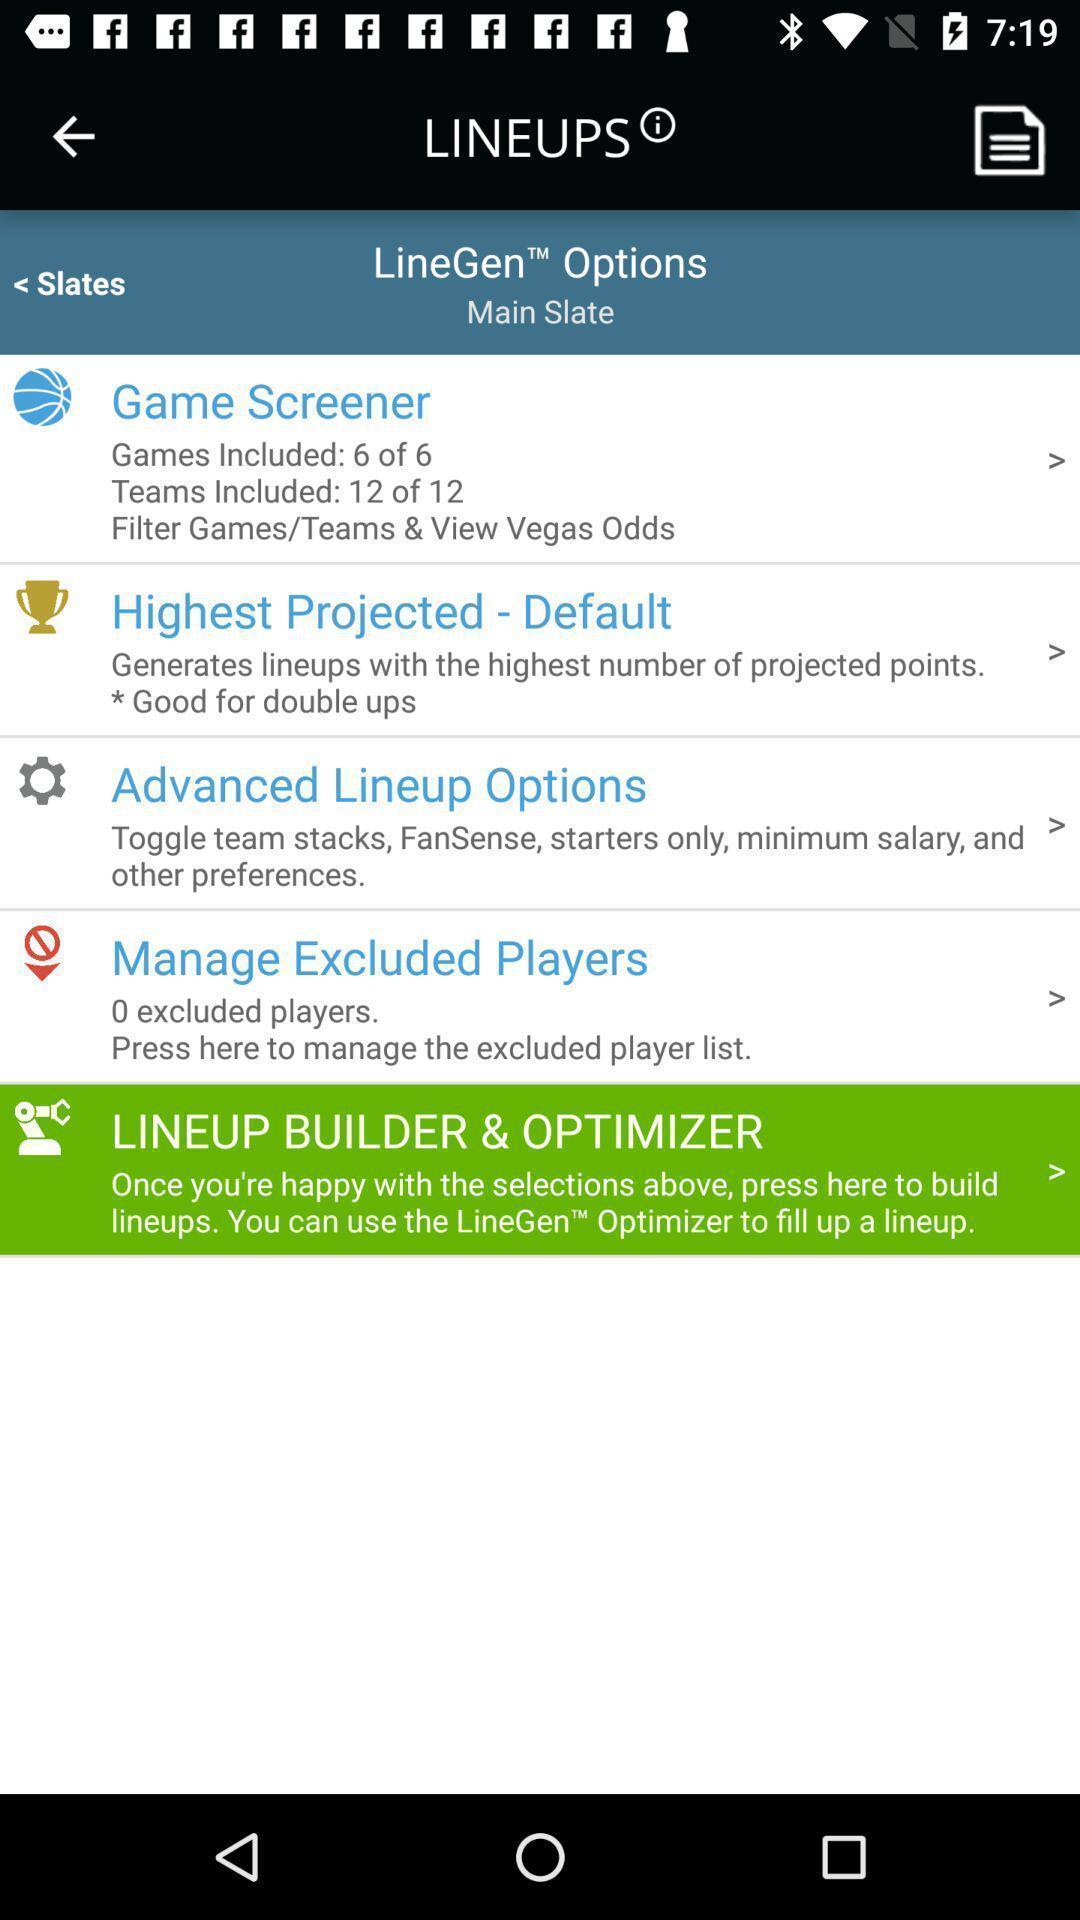Tell me about the visual elements in this screen capture. Page showing the different lineup options. 